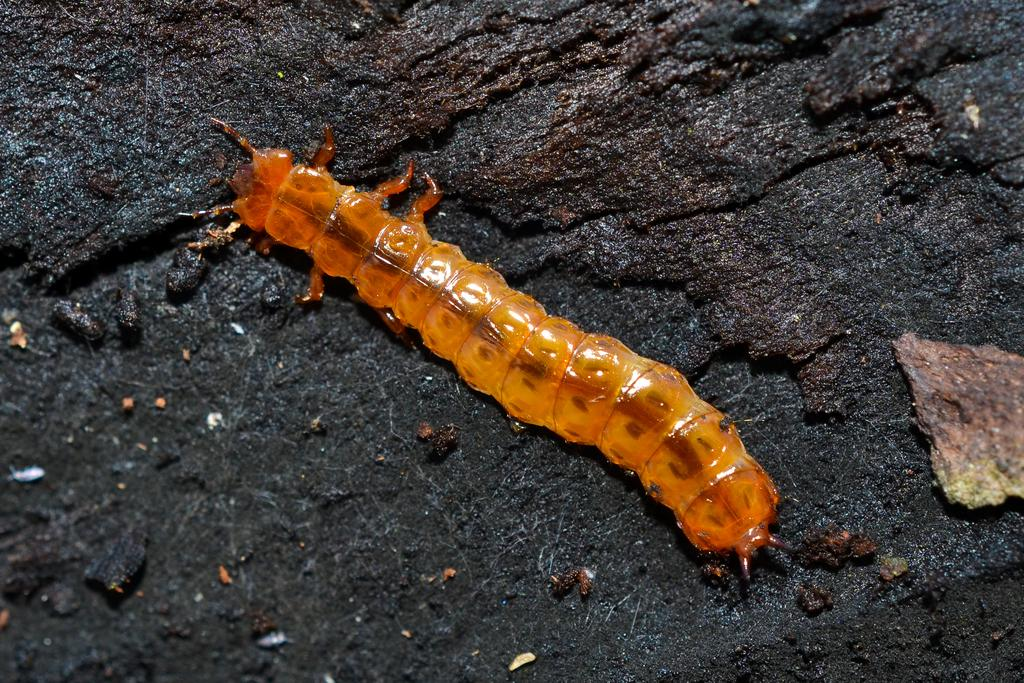What type of animal is in the image? There is a caterpillar in the image. Where is the caterpillar located? The caterpillar is on a surface. What color is the gold sofa in the image? There is no gold sofa present in the image; it only features a caterpillar on a surface. 